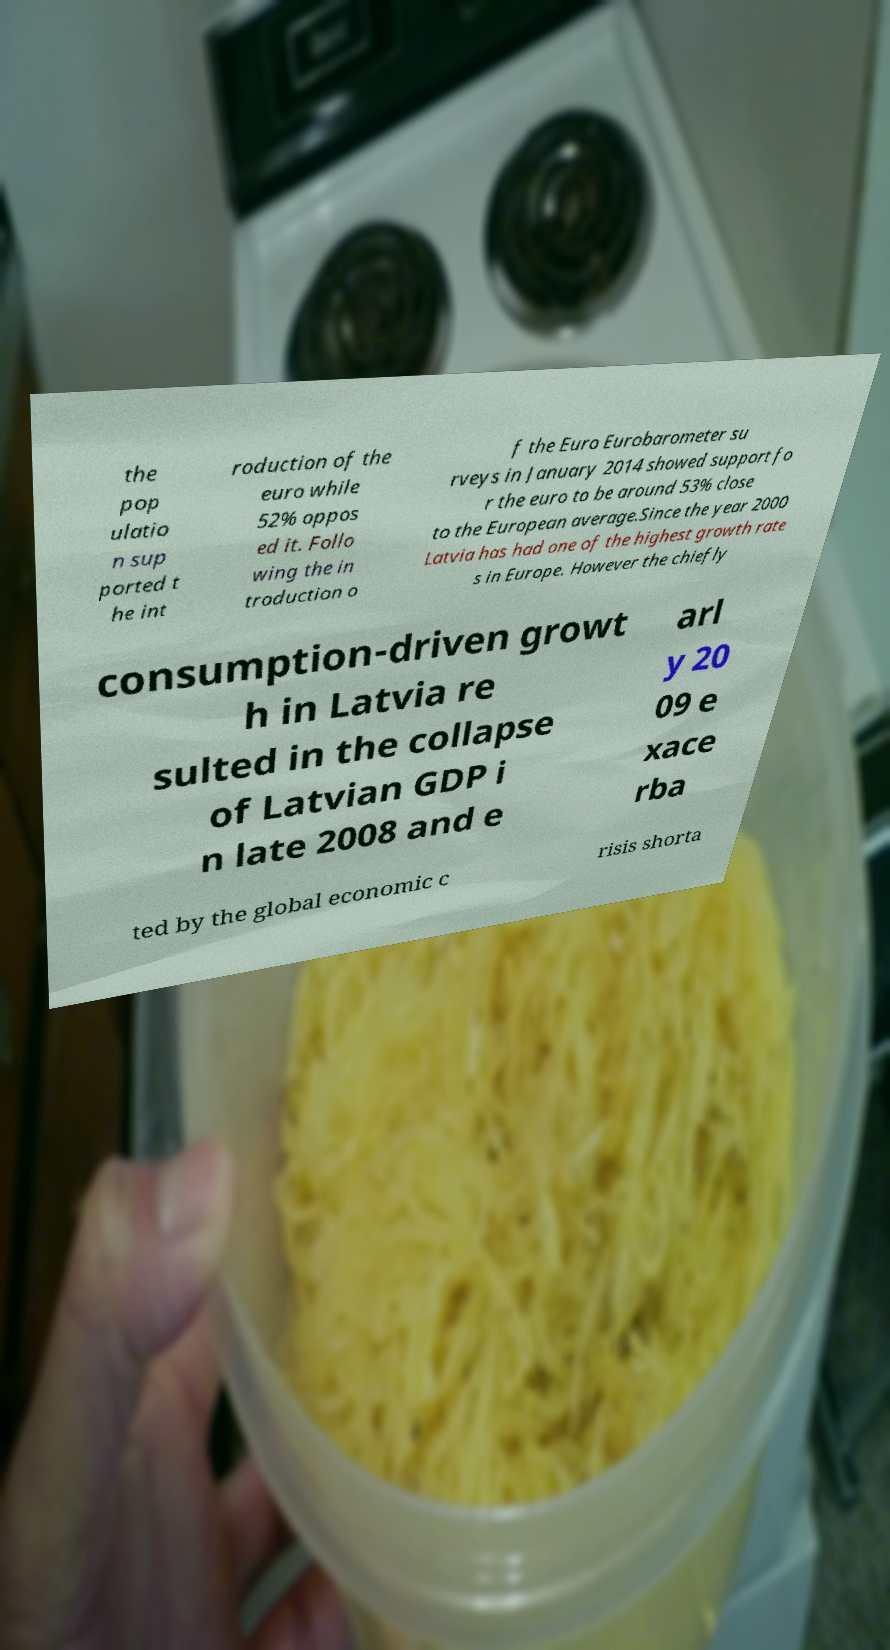Can you accurately transcribe the text from the provided image for me? the pop ulatio n sup ported t he int roduction of the euro while 52% oppos ed it. Follo wing the in troduction o f the Euro Eurobarometer su rveys in January 2014 showed support fo r the euro to be around 53% close to the European average.Since the year 2000 Latvia has had one of the highest growth rate s in Europe. However the chiefly consumption-driven growt h in Latvia re sulted in the collapse of Latvian GDP i n late 2008 and e arl y 20 09 e xace rba ted by the global economic c risis shorta 